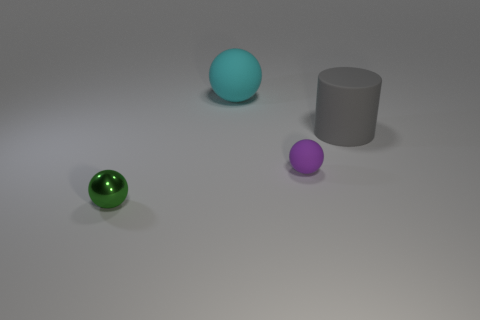Are there any other things that are the same material as the green ball?
Your response must be concise. No. Are there an equal number of big gray rubber objects left of the big rubber ball and matte spheres behind the large gray matte object?
Your answer should be compact. No. What number of gray rubber objects are to the right of the tiny purple rubber object?
Your answer should be very brief. 1. How many objects are small gray matte cubes or balls?
Your answer should be very brief. 3. What number of other purple matte objects are the same size as the purple object?
Your answer should be compact. 0. What shape is the big matte object that is on the left side of the large matte thing that is in front of the cyan matte sphere?
Offer a terse response. Sphere. Is the number of rubber cylinders less than the number of green rubber things?
Give a very brief answer. No. There is a tiny sphere left of the small matte object; what color is it?
Make the answer very short. Green. The thing that is in front of the big gray cylinder and right of the cyan matte ball is made of what material?
Keep it short and to the point. Rubber. What shape is the big object that is the same material as the cyan ball?
Give a very brief answer. Cylinder. 